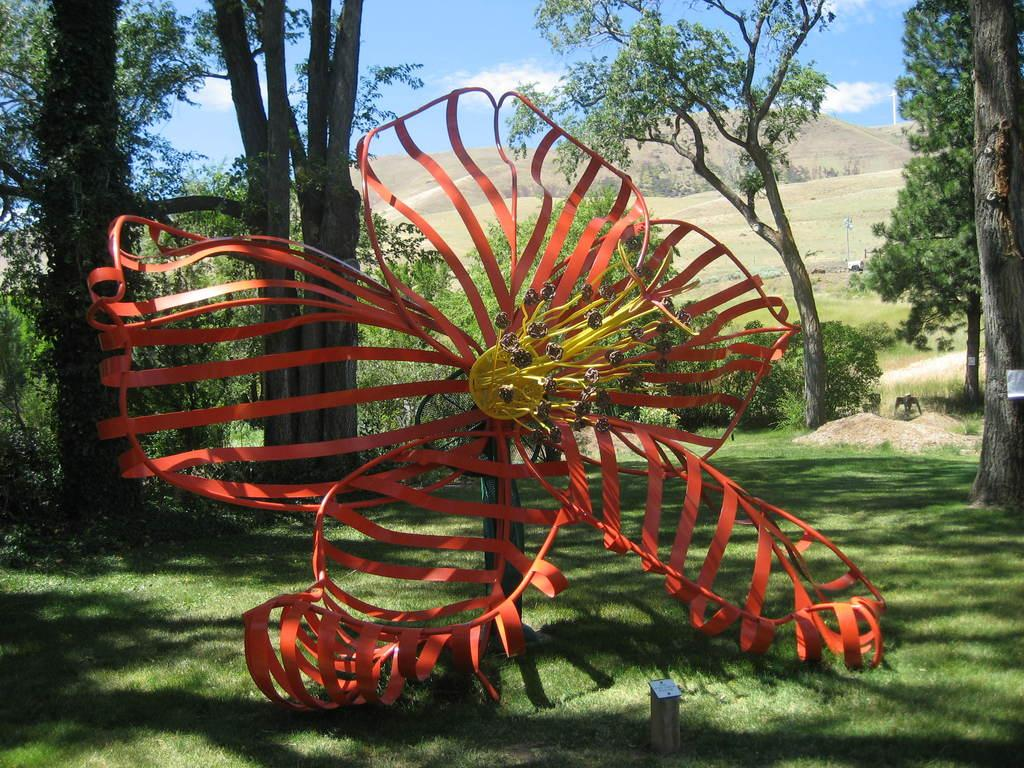What is the color of the object in the image? The object in the image is orange and yellow in color. What can be seen in the background of the image? There are trees and mountains visible in the background of the image. What is visible at the top of the image? The sky is visible at the top of the image. What type of pie is being served on the hill in the image? There is no pie or hill present in the image; it features an orange and yellow object, trees, mountains, and the sky. 